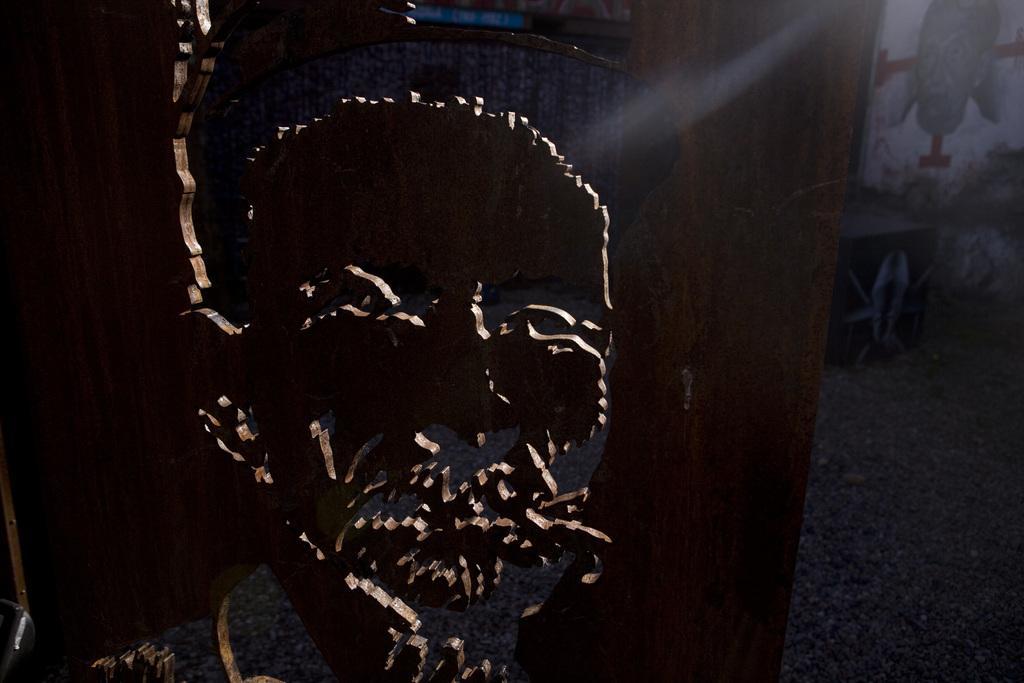In one or two sentences, can you explain what this image depicts? In this image there is a wooden board. There is a face of a person carved on the wooden board. To the right there is a wall. There is a painting of a person on the wall. 